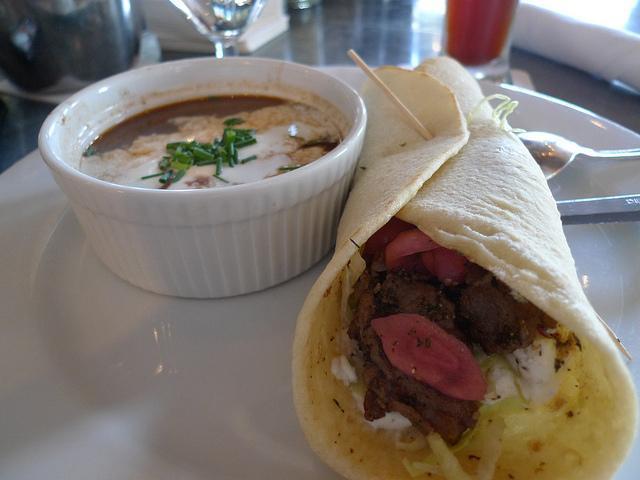Is the statement "The sandwich is near the bowl." accurate regarding the image?
Answer yes or no. Yes. 